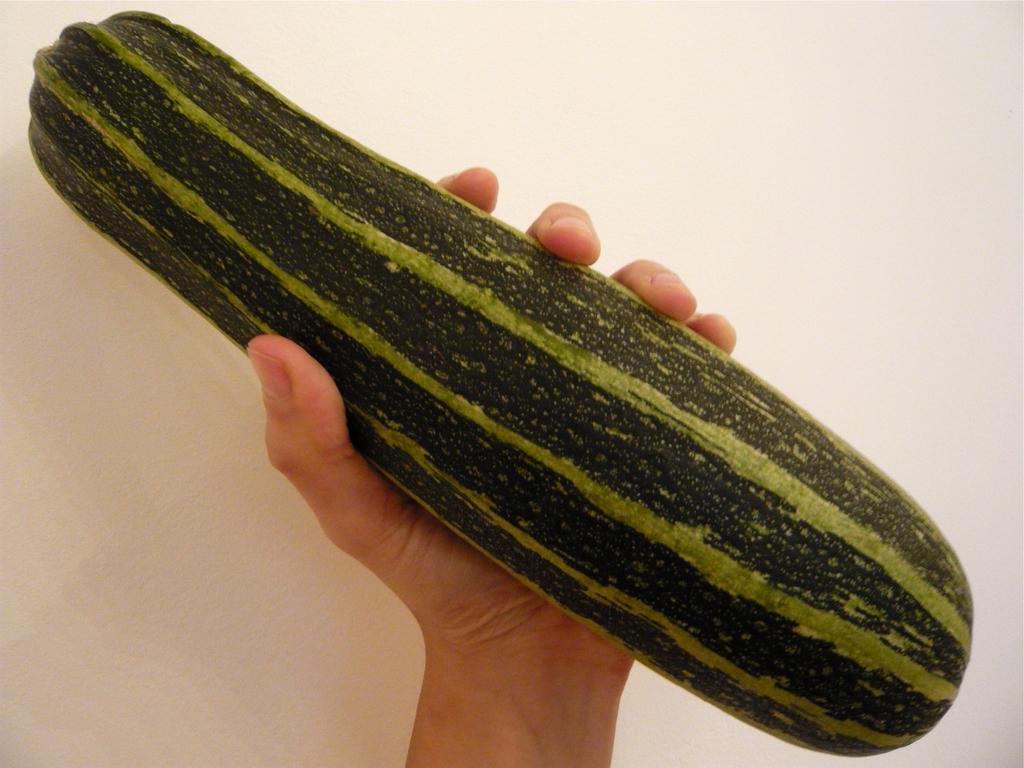Can you describe this image briefly? In this image we can see a vegetable in the person's hand. And there is a white colored background. 